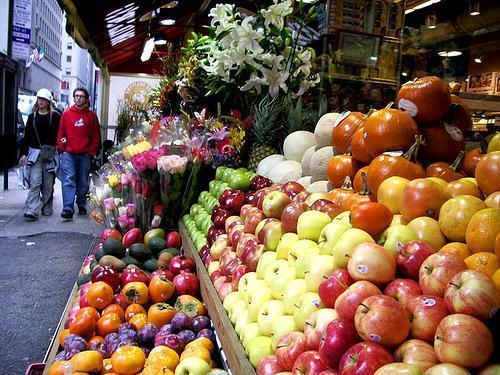How many people are wearing red shirt?
Give a very brief answer. 0. 